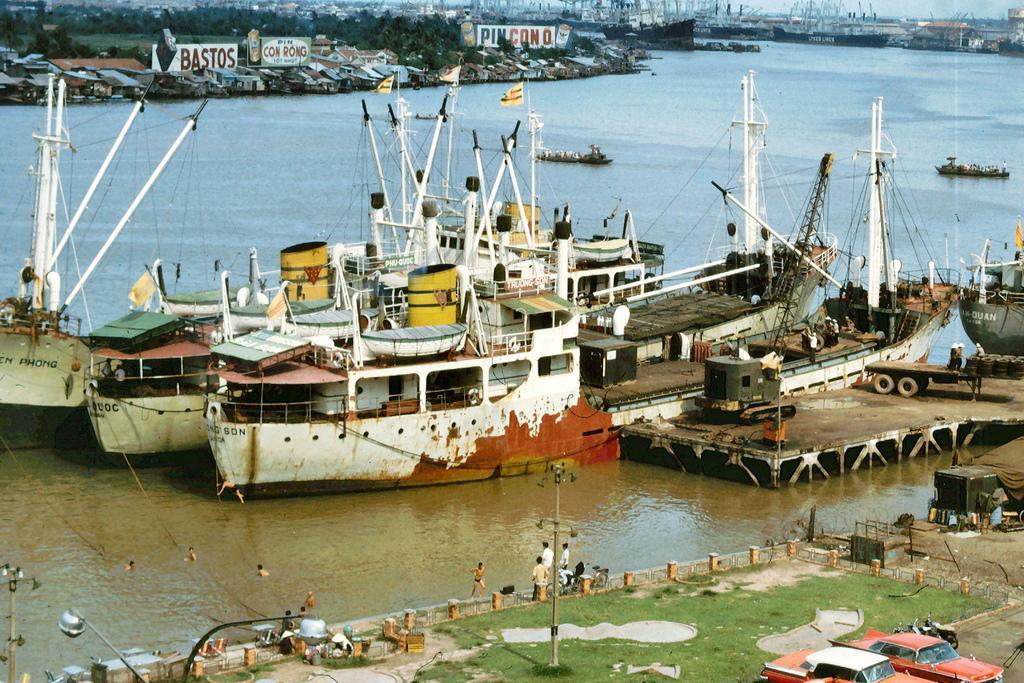Please provide a concise description of this image. On the right side, there are vehicles on the road. On the left side, there are persons in the water and there are persons on the footpath. In the background, there are boats on the water, there are houses and there are trees. 